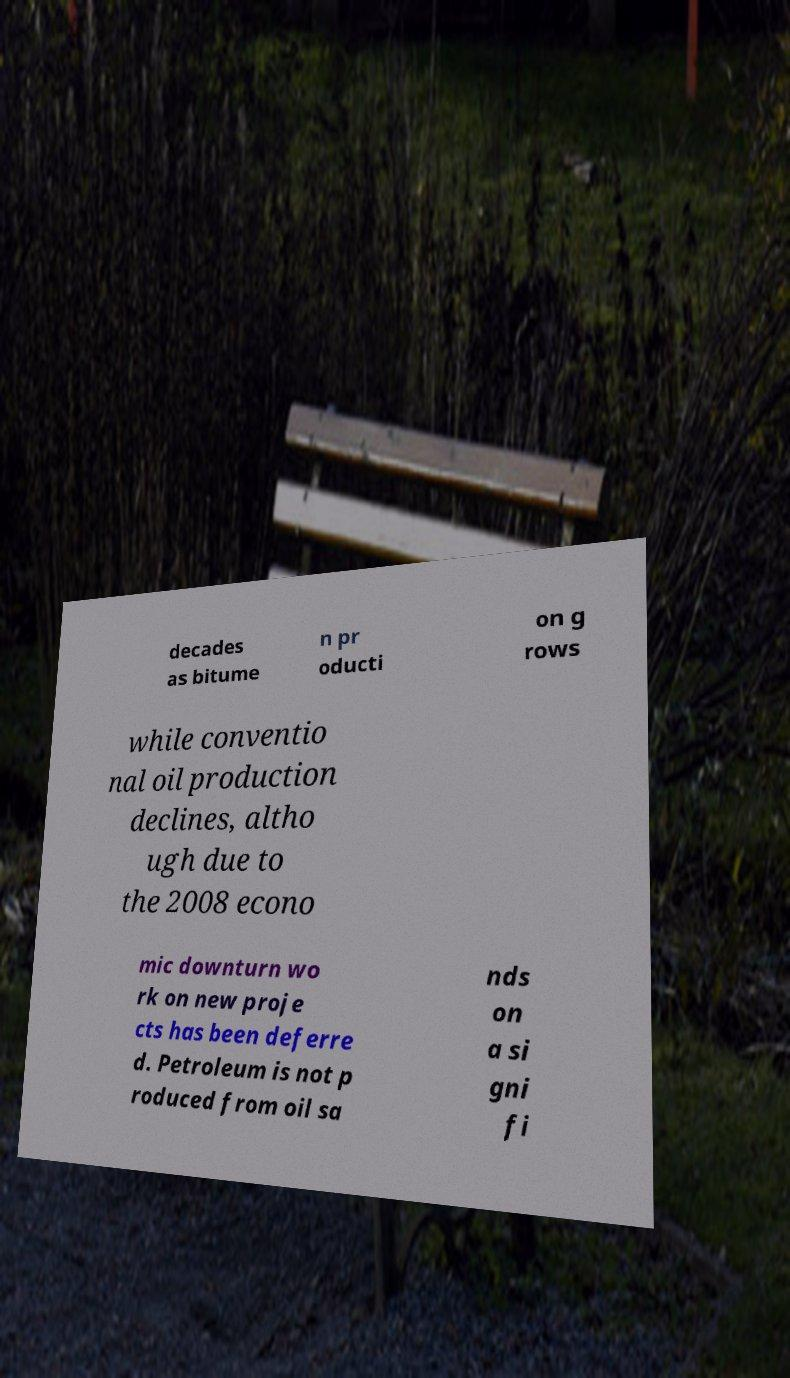Could you assist in decoding the text presented in this image and type it out clearly? decades as bitume n pr oducti on g rows while conventio nal oil production declines, altho ugh due to the 2008 econo mic downturn wo rk on new proje cts has been deferre d. Petroleum is not p roduced from oil sa nds on a si gni fi 